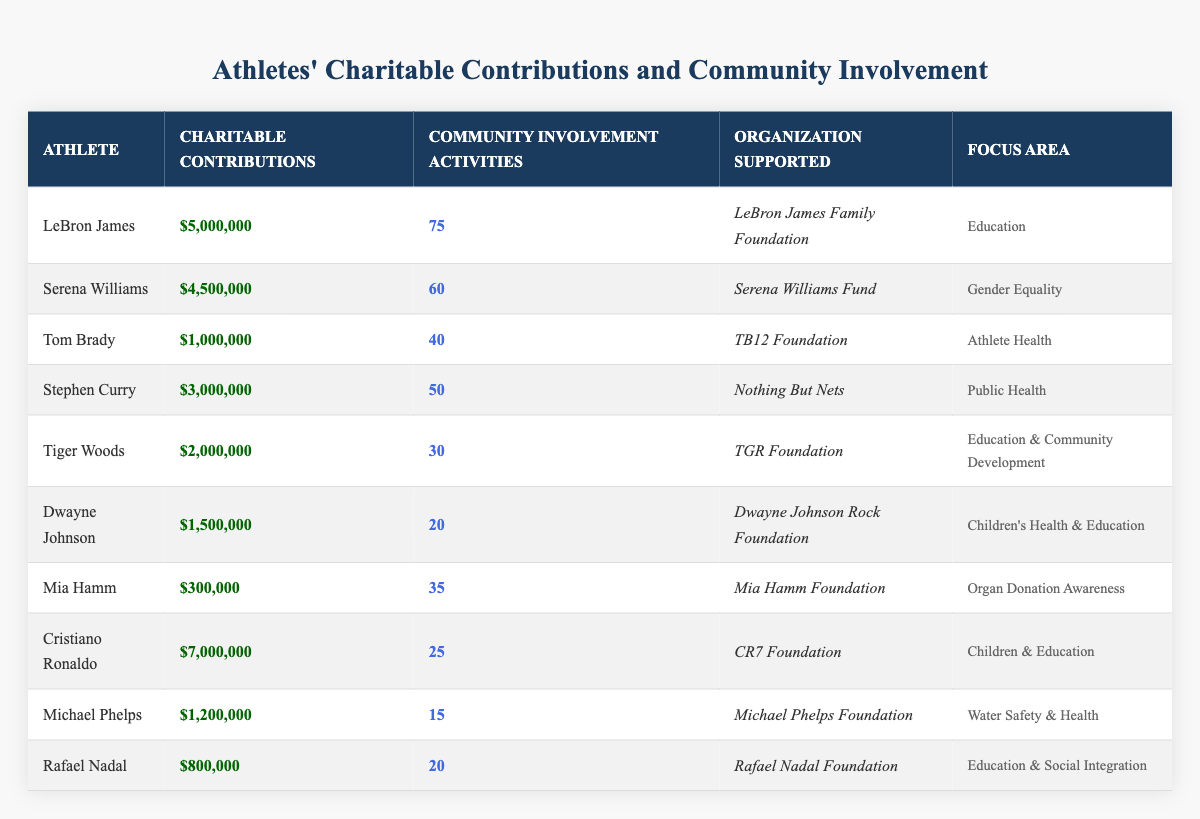What is the total amount of charitable contributions made by all the athletes? To find the total, sum the individual contributions: 5,000,000 + 4,500,000 + 1,000,000 + 3,000,000 + 2,000,000 + 1,500,000 + 300,000 + 7,000,000 + 1,200,000 + 800,000 = 26,300,000.
Answer: 26,300,000 Which athlete contributed the least to charitable causes? The least contribution is found by comparing all the values; Mia Hamm made the smallest contribution of 300,000.
Answer: Mia Hamm What focus area does the organization associated with LeBron James support? Look for the row with LeBron James; the focus area for his organization (LeBron James Family Foundation) is Education.
Answer: Education How many community involvement activities did Cristiano Ronaldo participate in? Refer to Cristiano Ronaldo's row; he has 25 community involvement activities.
Answer: 25 Is it true that Stephen Curry contributed more than Tom Brady? Compare their contributions: Stephen Curry contributed 3,000,000 while Tom Brady contributed 1,000,000; since 3,000,000 > 1,000,000, the statement is true.
Answer: Yes What is the average number of community involvement activities across all athletes? First, sum the activities: 75 + 60 + 40 + 50 + 30 + 20 + 35 + 25 + 15 + 20 = 430. Then divide by the number of athletes (10): 430 / 10 = 43.
Answer: 43 Which athlete contributed to both education and community development? Review the focus areas in the table; Tiger Woods supports "Education & Community Development."
Answer: Tiger Woods How many athletes have contributed more than 2 million dollars to charity? Check each contribution; athletes with contributions over 2 million are: LeBron James, Serena Williams, and Cristiano Ronaldo (which totals 3 athletes).
Answer: 3 What is the difference in number of community involvement activities between Serena Williams and Dwayne Johnson? Serena Williams has 60 activities, and Dwayne Johnson has 20 activities. The difference is 60 - 20 = 40.
Answer: 40 Which athlete supports gender equality? Find the focus area of each athlete; Serena Williams supports gender equality through her organization.
Answer: Serena Williams 